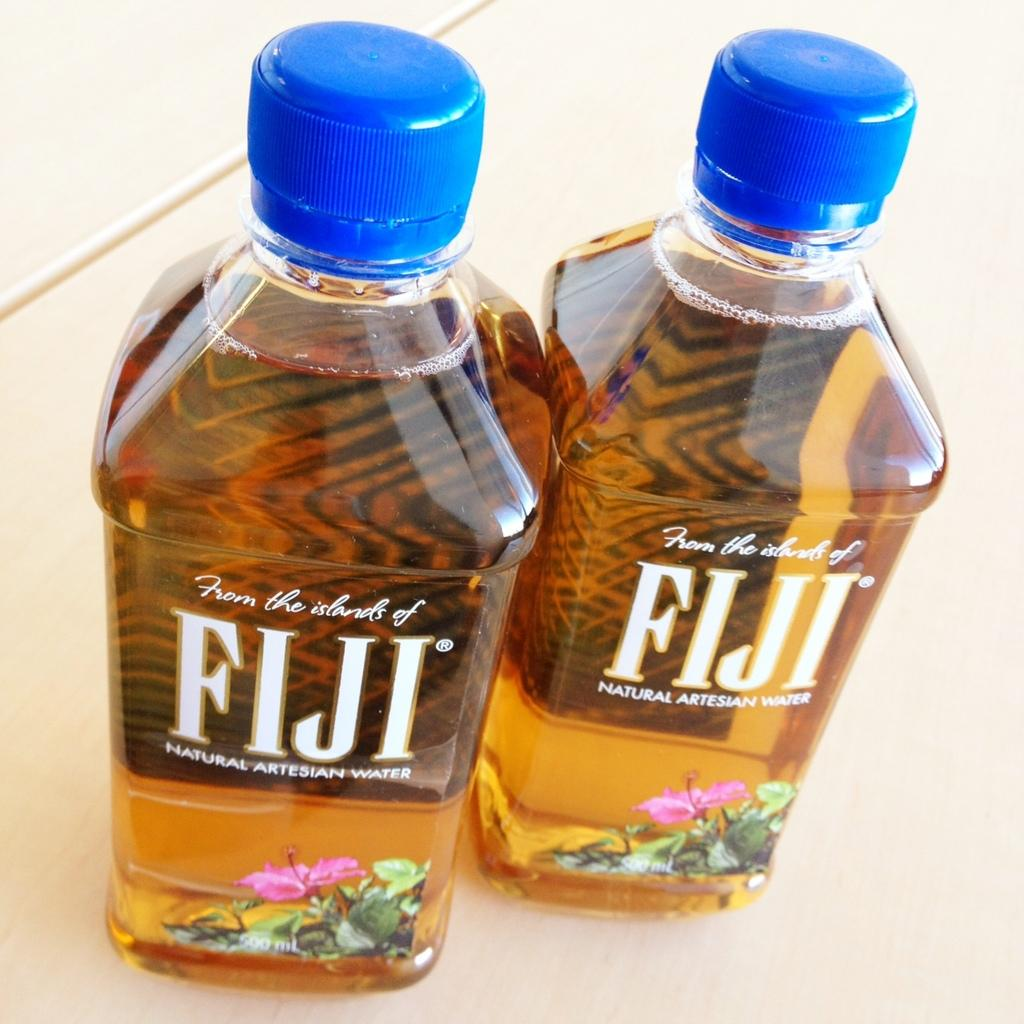<image>
Relay a brief, clear account of the picture shown. Two bottles of Fiji natural artesian water have a brown liquid in them. 